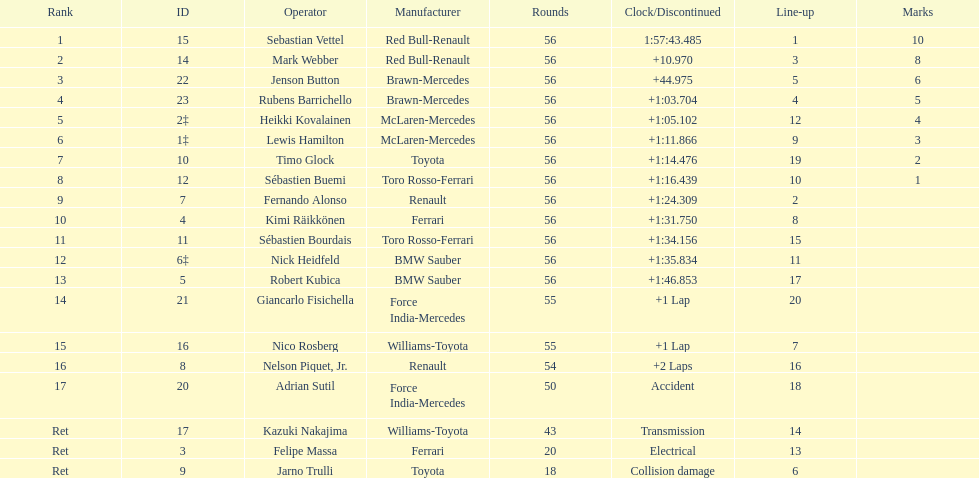What is the name of a driver that ferrari was not a constructor for? Sebastian Vettel. 